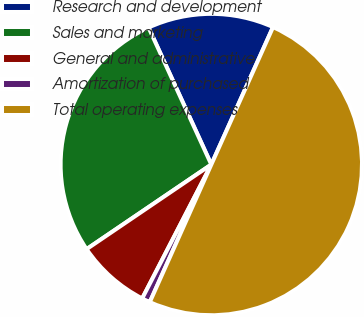Convert chart. <chart><loc_0><loc_0><loc_500><loc_500><pie_chart><fcel>Research and development<fcel>Sales and marketing<fcel>General and administrative<fcel>Amortization of purchased<fcel>Total operating expenses<nl><fcel>13.55%<fcel>27.65%<fcel>7.93%<fcel>0.89%<fcel>49.97%<nl></chart> 